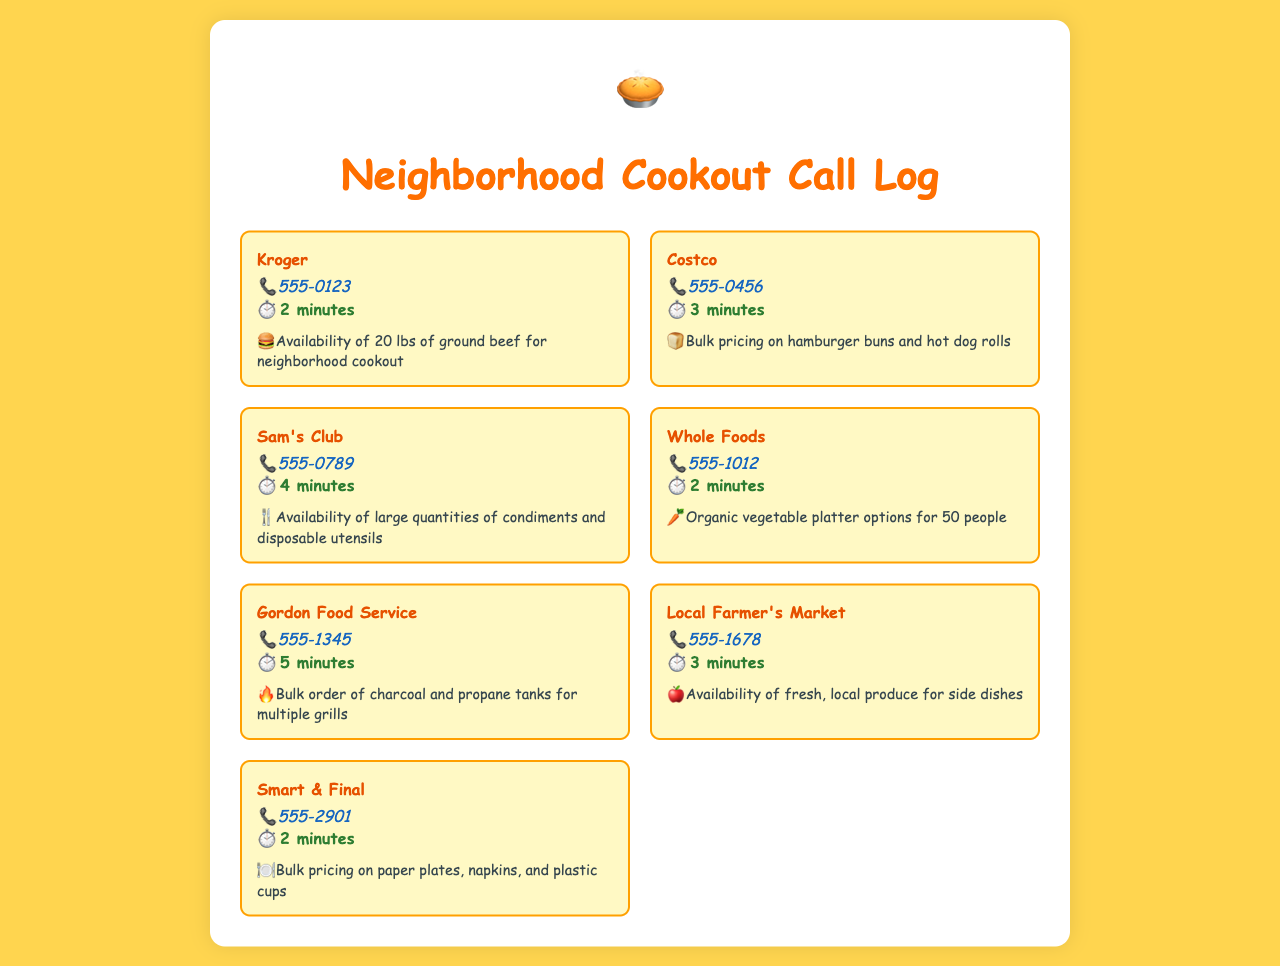What store did you call for ground beef? The document lists the store called for ground beef, which is Kroger.
Answer: Kroger How long was the call to Whole Foods? The duration of the call to Whole Foods is directly provided in the document.
Answer: 2 minutes Which store offers organic vegetable platter options? The store that offers organic vegetable platter options is specified in the inquiry for Whole Foods.
Answer: Whole Foods What item was inquired about at Local Farmer's Market? The specific inquiry made to Local Farmer's Market relates to fresh produce for side dishes.
Answer: Fresh, local produce How many stores were contacted for bulk item inquiries? To determine this, count all unique stores listed in the document, which is a total of six.
Answer: 7 What type of utensils were asked about at Sam's Club? The inquiry at Sam's Club mentions large quantities of disposable utensils.
Answer: Disposable utensils Which store offers bulk pricing on paper plates? The inquiry for bulk pricing on paper plates was made to Smart & Final.
Answer: Smart & Final What was the duration of the call to Gordon Food Service? The duration of the call to Gordon Food Service, as provided in the document, specifies it.
Answer: 5 minutes 